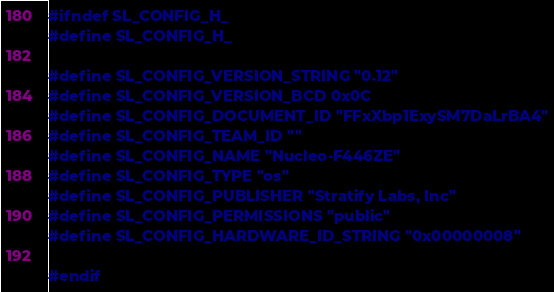Convert code to text. <code><loc_0><loc_0><loc_500><loc_500><_C_>
#ifndef SL_CONFIG_H_
#define SL_CONFIG_H_

#define SL_CONFIG_VERSION_STRING "0.12"
#define SL_CONFIG_VERSION_BCD 0x0C
#define SL_CONFIG_DOCUMENT_ID "FFxXbp1ExySM7DaLrBA4"
#define SL_CONFIG_TEAM_ID ""
#define SL_CONFIG_NAME "Nucleo-F446ZE"
#define SL_CONFIG_TYPE "os"
#define SL_CONFIG_PUBLISHER "Stratify Labs, Inc"
#define SL_CONFIG_PERMISSIONS "public"
#define SL_CONFIG_HARDWARE_ID_STRING "0x00000008"

#endif

</code> 